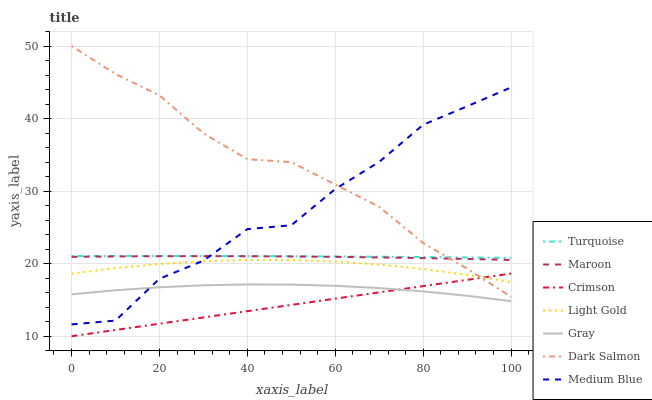Does Crimson have the minimum area under the curve?
Answer yes or no. Yes. Does Dark Salmon have the maximum area under the curve?
Answer yes or no. Yes. Does Turquoise have the minimum area under the curve?
Answer yes or no. No. Does Turquoise have the maximum area under the curve?
Answer yes or no. No. Is Crimson the smoothest?
Answer yes or no. Yes. Is Medium Blue the roughest?
Answer yes or no. Yes. Is Turquoise the smoothest?
Answer yes or no. No. Is Turquoise the roughest?
Answer yes or no. No. Does Crimson have the lowest value?
Answer yes or no. Yes. Does Medium Blue have the lowest value?
Answer yes or no. No. Does Dark Salmon have the highest value?
Answer yes or no. Yes. Does Turquoise have the highest value?
Answer yes or no. No. Is Crimson less than Maroon?
Answer yes or no. Yes. Is Turquoise greater than Maroon?
Answer yes or no. Yes. Does Medium Blue intersect Dark Salmon?
Answer yes or no. Yes. Is Medium Blue less than Dark Salmon?
Answer yes or no. No. Is Medium Blue greater than Dark Salmon?
Answer yes or no. No. Does Crimson intersect Maroon?
Answer yes or no. No. 